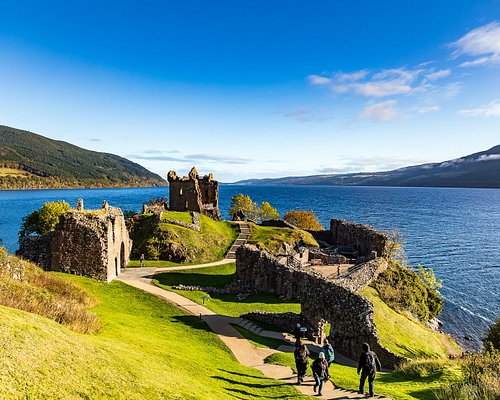Describe the following image. The image portrays the striking ruins of Urquhart Castle, set against the picturesque backdrop of Loch Ness in Scotland. The castle's stone walls, weathered by time, rise from a lush, grassy hill, providing a commanding view of the shimmering loch below. Nature has reclaimed parts of the structure, with greenery creeping up the stone, creating a harmonious blend of history and nature. The sky is a brilliant blue, reflecting the vibrant hues of the lake's deep blue-green waters. A meandering path leads up to the castle, inviting explorers to delve into its storied past and soak in the breathtaking scenery. Several visitors can be seen strolling along the path, adding a dynamic, human element to this tranquil and historic landscape. 